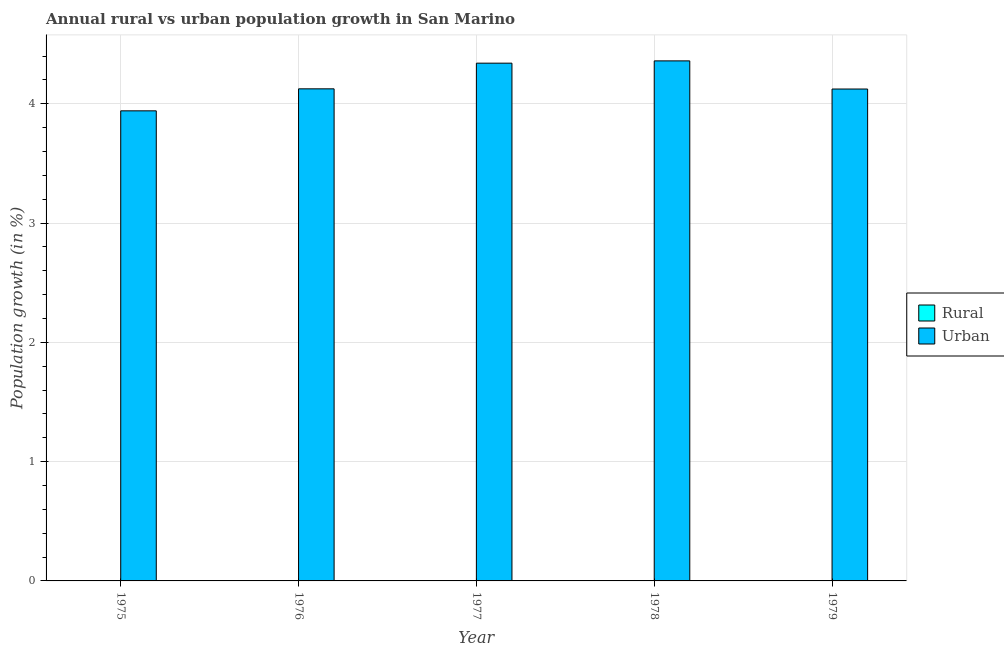How many different coloured bars are there?
Provide a short and direct response. 1. Are the number of bars per tick equal to the number of legend labels?
Make the answer very short. No. Are the number of bars on each tick of the X-axis equal?
Make the answer very short. Yes. How many bars are there on the 5th tick from the right?
Your answer should be very brief. 1. What is the urban population growth in 1976?
Provide a succinct answer. 4.13. Across all years, what is the maximum urban population growth?
Keep it short and to the point. 4.36. Across all years, what is the minimum urban population growth?
Keep it short and to the point. 3.94. In which year was the urban population growth maximum?
Provide a succinct answer. 1978. What is the total urban population growth in the graph?
Your answer should be compact. 20.89. What is the difference between the urban population growth in 1975 and that in 1978?
Provide a short and direct response. -0.42. What is the average urban population growth per year?
Your response must be concise. 4.18. What is the ratio of the urban population growth in 1976 to that in 1978?
Your answer should be very brief. 0.95. Is the urban population growth in 1977 less than that in 1979?
Provide a short and direct response. No. Is the difference between the urban population growth in 1975 and 1978 greater than the difference between the rural population growth in 1975 and 1978?
Your answer should be compact. No. What is the difference between the highest and the second highest urban population growth?
Offer a terse response. 0.02. What is the difference between the highest and the lowest urban population growth?
Provide a short and direct response. 0.42. How many bars are there?
Provide a succinct answer. 5. How many years are there in the graph?
Offer a very short reply. 5. What is the difference between two consecutive major ticks on the Y-axis?
Offer a terse response. 1. How many legend labels are there?
Provide a succinct answer. 2. How are the legend labels stacked?
Offer a terse response. Vertical. What is the title of the graph?
Provide a short and direct response. Annual rural vs urban population growth in San Marino. Does "Working only" appear as one of the legend labels in the graph?
Keep it short and to the point. No. What is the label or title of the X-axis?
Offer a terse response. Year. What is the label or title of the Y-axis?
Your answer should be compact. Population growth (in %). What is the Population growth (in %) in Urban  in 1975?
Provide a succinct answer. 3.94. What is the Population growth (in %) in Rural in 1976?
Your answer should be compact. 0. What is the Population growth (in %) in Urban  in 1976?
Give a very brief answer. 4.13. What is the Population growth (in %) in Urban  in 1977?
Provide a short and direct response. 4.34. What is the Population growth (in %) of Urban  in 1978?
Your answer should be compact. 4.36. What is the Population growth (in %) in Rural in 1979?
Keep it short and to the point. 0. What is the Population growth (in %) in Urban  in 1979?
Provide a succinct answer. 4.12. Across all years, what is the maximum Population growth (in %) of Urban ?
Offer a very short reply. 4.36. Across all years, what is the minimum Population growth (in %) of Urban ?
Offer a terse response. 3.94. What is the total Population growth (in %) in Urban  in the graph?
Make the answer very short. 20.89. What is the difference between the Population growth (in %) in Urban  in 1975 and that in 1976?
Keep it short and to the point. -0.18. What is the difference between the Population growth (in %) of Urban  in 1975 and that in 1977?
Give a very brief answer. -0.4. What is the difference between the Population growth (in %) of Urban  in 1975 and that in 1978?
Offer a terse response. -0.42. What is the difference between the Population growth (in %) of Urban  in 1975 and that in 1979?
Your answer should be very brief. -0.18. What is the difference between the Population growth (in %) of Urban  in 1976 and that in 1977?
Ensure brevity in your answer.  -0.22. What is the difference between the Population growth (in %) of Urban  in 1976 and that in 1978?
Provide a succinct answer. -0.23. What is the difference between the Population growth (in %) of Urban  in 1976 and that in 1979?
Make the answer very short. 0. What is the difference between the Population growth (in %) of Urban  in 1977 and that in 1978?
Keep it short and to the point. -0.02. What is the difference between the Population growth (in %) of Urban  in 1977 and that in 1979?
Provide a short and direct response. 0.22. What is the difference between the Population growth (in %) of Urban  in 1978 and that in 1979?
Your answer should be compact. 0.24. What is the average Population growth (in %) in Rural per year?
Ensure brevity in your answer.  0. What is the average Population growth (in %) of Urban  per year?
Offer a very short reply. 4.18. What is the ratio of the Population growth (in %) in Urban  in 1975 to that in 1976?
Your response must be concise. 0.96. What is the ratio of the Population growth (in %) in Urban  in 1975 to that in 1977?
Your answer should be very brief. 0.91. What is the ratio of the Population growth (in %) in Urban  in 1975 to that in 1978?
Give a very brief answer. 0.9. What is the ratio of the Population growth (in %) in Urban  in 1975 to that in 1979?
Provide a succinct answer. 0.96. What is the ratio of the Population growth (in %) in Urban  in 1976 to that in 1977?
Make the answer very short. 0.95. What is the ratio of the Population growth (in %) in Urban  in 1976 to that in 1978?
Offer a terse response. 0.95. What is the ratio of the Population growth (in %) in Urban  in 1977 to that in 1979?
Ensure brevity in your answer.  1.05. What is the ratio of the Population growth (in %) of Urban  in 1978 to that in 1979?
Provide a succinct answer. 1.06. What is the difference between the highest and the second highest Population growth (in %) in Urban ?
Your answer should be very brief. 0.02. What is the difference between the highest and the lowest Population growth (in %) of Urban ?
Your answer should be compact. 0.42. 